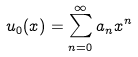<formula> <loc_0><loc_0><loc_500><loc_500>u _ { 0 } ( x ) = \sum ^ { \infty } _ { n = 0 } a _ { n } x ^ { n }</formula> 